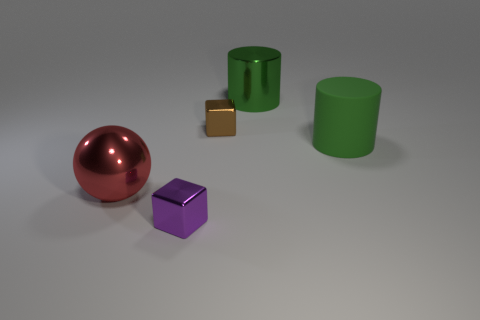Add 2 large brown metal objects. How many objects exist? 7 Subtract all blocks. How many objects are left? 3 Add 3 green objects. How many green objects are left? 5 Add 2 big things. How many big things exist? 5 Subtract 0 blue balls. How many objects are left? 5 Subtract all big yellow matte blocks. Subtract all small purple metallic blocks. How many objects are left? 4 